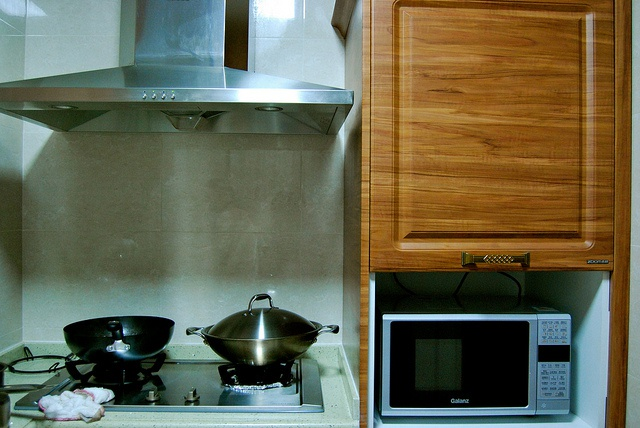Describe the objects in this image and their specific colors. I can see oven in lightblue, black, teal, and darkgray tones and microwave in lightblue, black, gray, and blue tones in this image. 